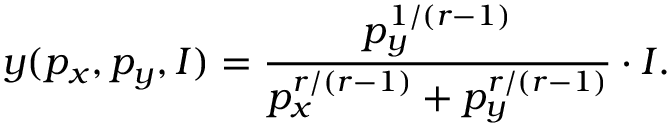Convert formula to latex. <formula><loc_0><loc_0><loc_500><loc_500>y ( p _ { x } , p _ { y } , I ) = { \frac { p _ { y } ^ { 1 / ( r - 1 ) } } { p _ { x } ^ { r / ( r - 1 ) } + p _ { y } ^ { r / ( r - 1 ) } } } \cdot I .</formula> 